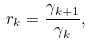<formula> <loc_0><loc_0><loc_500><loc_500>r _ { k } = \frac { \gamma _ { k + 1 } } { \gamma _ { k } } ,</formula> 